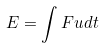Convert formula to latex. <formula><loc_0><loc_0><loc_500><loc_500>E = \int F u d t</formula> 